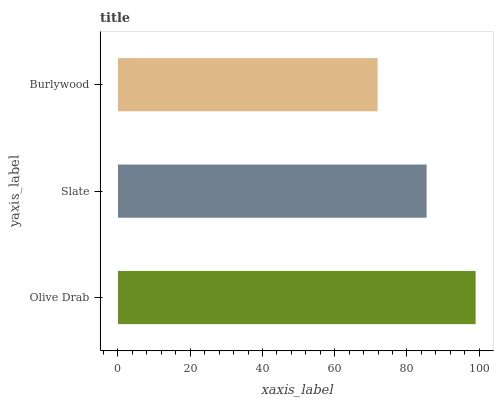Is Burlywood the minimum?
Answer yes or no. Yes. Is Olive Drab the maximum?
Answer yes or no. Yes. Is Slate the minimum?
Answer yes or no. No. Is Slate the maximum?
Answer yes or no. No. Is Olive Drab greater than Slate?
Answer yes or no. Yes. Is Slate less than Olive Drab?
Answer yes or no. Yes. Is Slate greater than Olive Drab?
Answer yes or no. No. Is Olive Drab less than Slate?
Answer yes or no. No. Is Slate the high median?
Answer yes or no. Yes. Is Slate the low median?
Answer yes or no. Yes. Is Burlywood the high median?
Answer yes or no. No. Is Burlywood the low median?
Answer yes or no. No. 